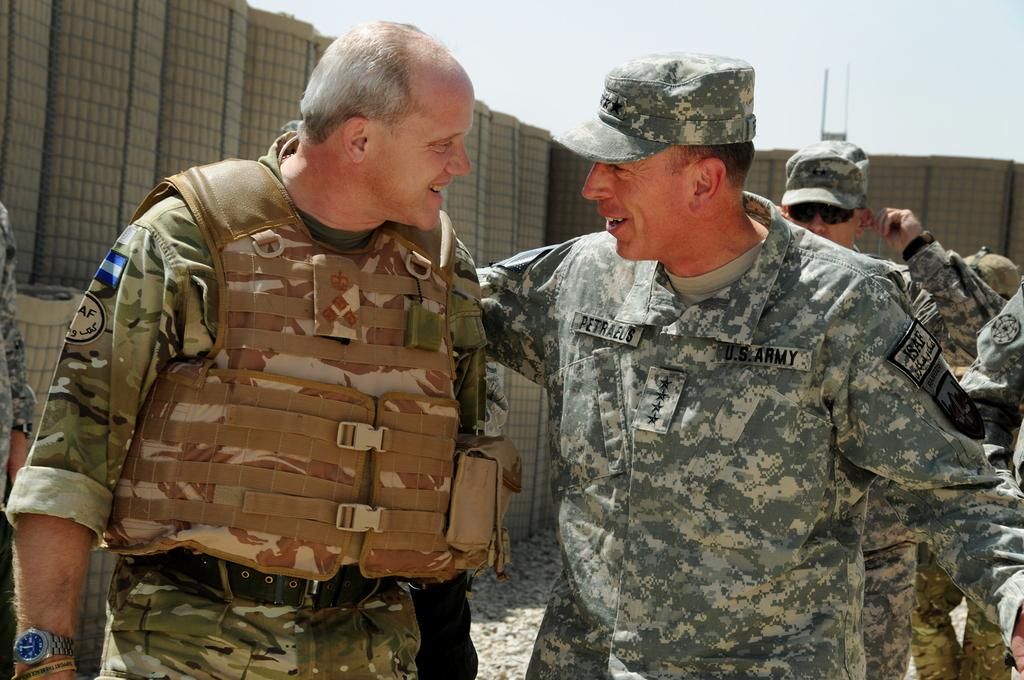How many military soldiers are in the image? There are two military soldiers in the image. Where are the soldiers positioned in the image? The soldiers are standing in the front. What are the soldiers doing in the image? The soldiers are looking at each other and smiling. What can be seen in the background of the image? There is a boundary wall visible in the background. What type of camera is the soldier holding in the image? There is no camera visible in the image; the soldiers are not holding any objects. 